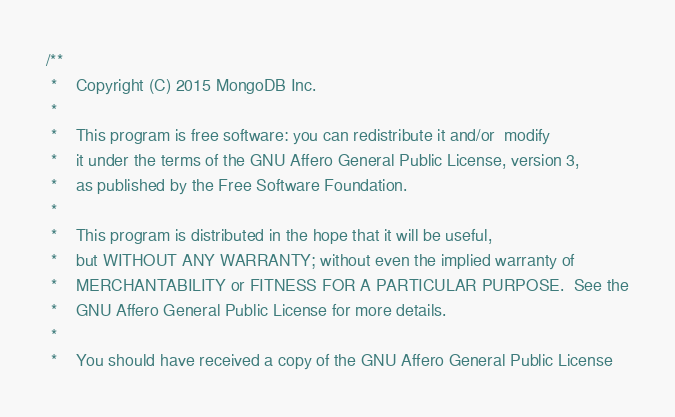<code> <loc_0><loc_0><loc_500><loc_500><_C++_>/**
 *    Copyright (C) 2015 MongoDB Inc.
 *
 *    This program is free software: you can redistribute it and/or  modify
 *    it under the terms of the GNU Affero General Public License, version 3,
 *    as published by the Free Software Foundation.
 *
 *    This program is distributed in the hope that it will be useful,
 *    but WITHOUT ANY WARRANTY; without even the implied warranty of
 *    MERCHANTABILITY or FITNESS FOR A PARTICULAR PURPOSE.  See the
 *    GNU Affero General Public License for more details.
 *
 *    You should have received a copy of the GNU Affero General Public License</code> 